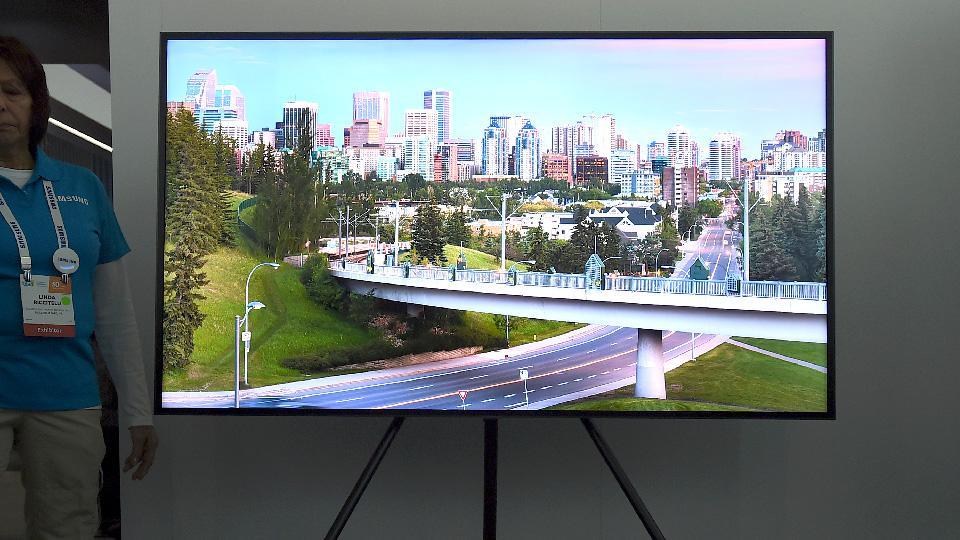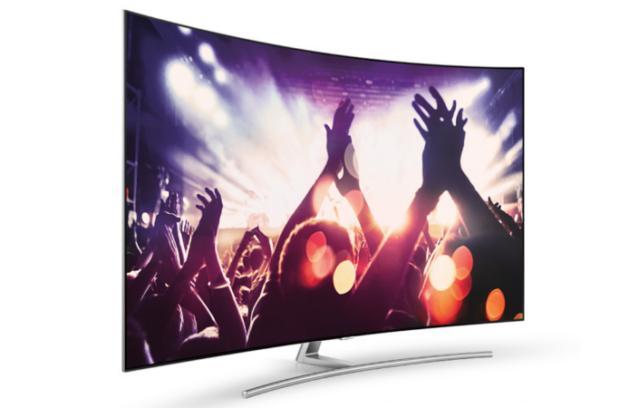The first image is the image on the left, the second image is the image on the right. For the images displayed, is the sentence "Each image contains a single screen, and left and right images feature different pictures on the screens." factually correct? Answer yes or no. Yes. The first image is the image on the left, the second image is the image on the right. Considering the images on both sides, is "there is a curved tv on a metal stand with wording in the corner" valid? Answer yes or no. No. 